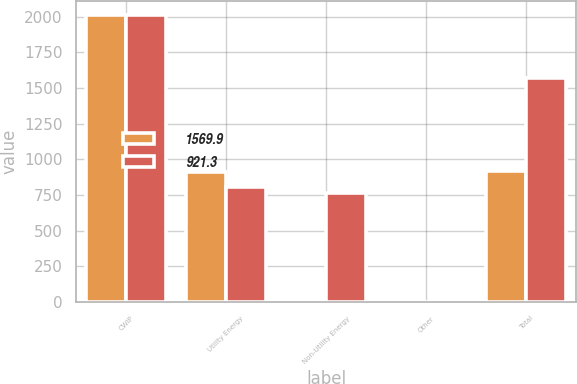<chart> <loc_0><loc_0><loc_500><loc_500><stacked_bar_chart><ecel><fcel>CWIP<fcel>Utility Energy<fcel>Non-Utility Energy<fcel>Other<fcel>Total<nl><fcel>1569.9<fcel>2011<fcel>910.3<fcel>8.9<fcel>2.1<fcel>921.3<nl><fcel>921.3<fcel>2010<fcel>806.9<fcel>761.3<fcel>1.7<fcel>1569.9<nl></chart> 